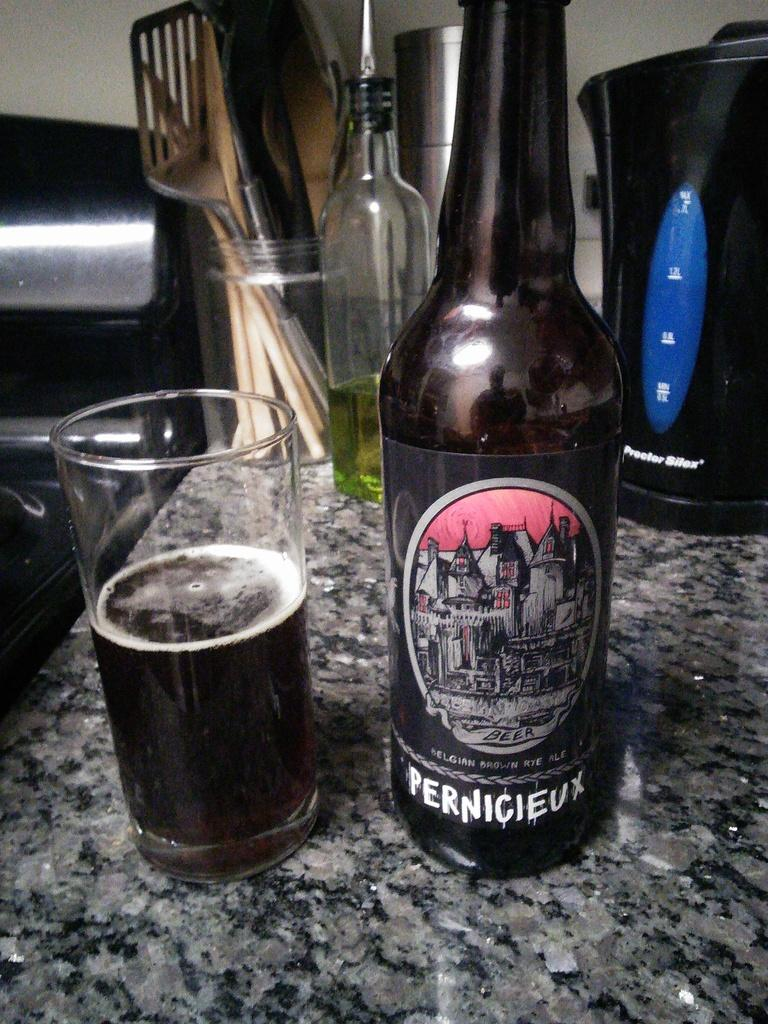<image>
Summarize the visual content of the image. stone counter toip with bottle of pernicieux and half full glass in front of kitchen utensils and proctor silex coffee pot 